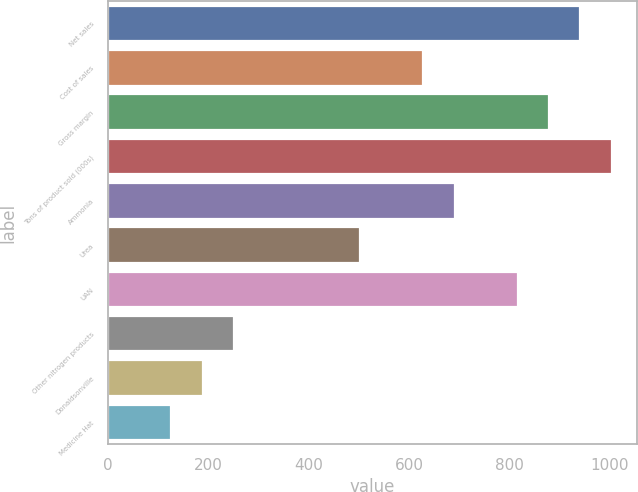<chart> <loc_0><loc_0><loc_500><loc_500><bar_chart><fcel>Net sales<fcel>Cost of sales<fcel>Gross margin<fcel>Tons of product sold (000s)<fcel>Ammonia<fcel>Urea<fcel>UAN<fcel>Other nitrogen products<fcel>Donaldsonville<fcel>Medicine Hat<nl><fcel>941.89<fcel>627.99<fcel>879.11<fcel>1004.67<fcel>690.77<fcel>502.43<fcel>816.33<fcel>251.31<fcel>188.53<fcel>125.75<nl></chart> 